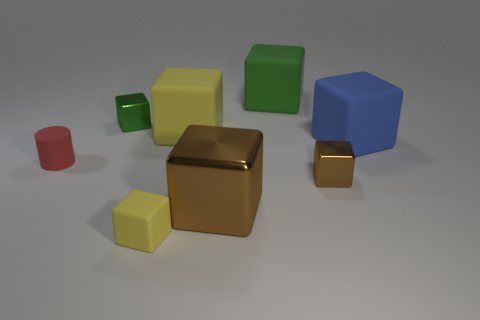What size is the cylinder?
Your answer should be very brief. Small. There is a tiny cylinder that is made of the same material as the small yellow thing; what color is it?
Your answer should be compact. Red. How many brown cylinders are made of the same material as the large brown thing?
Offer a terse response. 0. What number of objects are either tiny yellow objects or matte objects behind the blue matte thing?
Keep it short and to the point. 3. Do the large object in front of the small red thing and the big yellow object have the same material?
Your response must be concise. No. The matte block that is the same size as the red object is what color?
Your answer should be very brief. Yellow. Is there another matte thing of the same shape as the large yellow rubber object?
Offer a terse response. Yes. What is the color of the tiny object on the right side of the yellow object in front of the brown block that is to the right of the big metallic block?
Ensure brevity in your answer.  Brown. What number of metallic objects are large brown objects or blue blocks?
Your answer should be very brief. 1. Are there more large yellow rubber blocks that are in front of the tiny green shiny cube than brown things that are behind the rubber cylinder?
Give a very brief answer. Yes. 